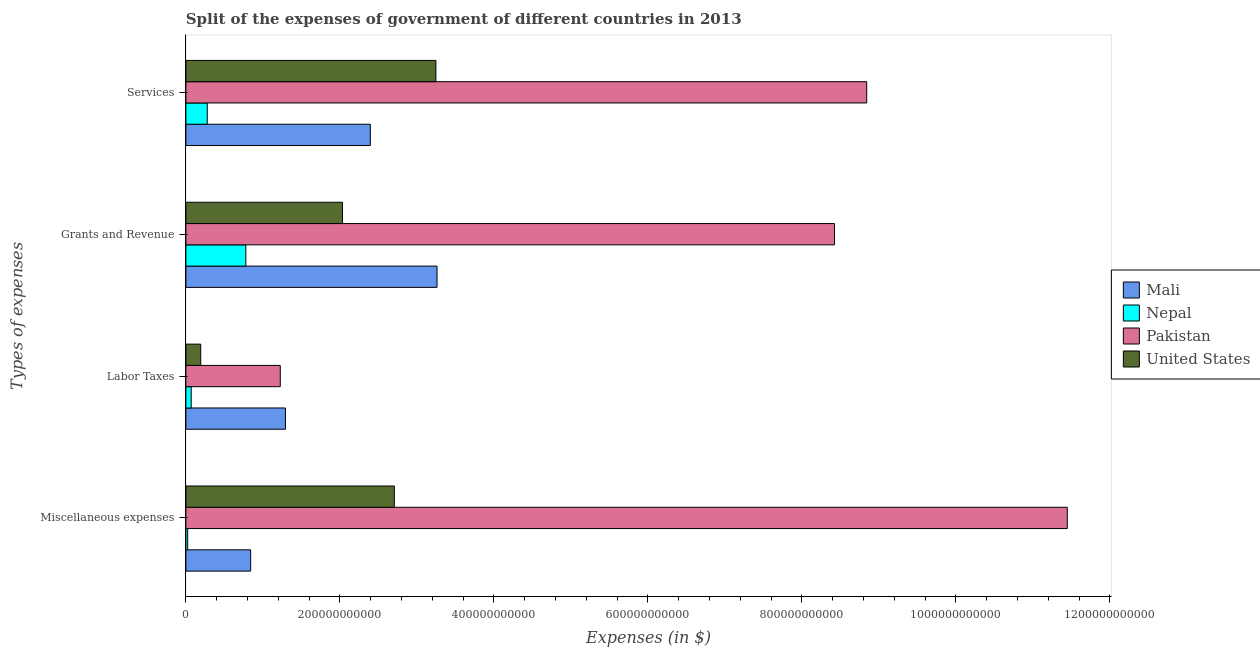How many different coloured bars are there?
Offer a terse response. 4. Are the number of bars on each tick of the Y-axis equal?
Provide a short and direct response. Yes. What is the label of the 3rd group of bars from the top?
Ensure brevity in your answer.  Labor Taxes. What is the amount spent on services in Mali?
Make the answer very short. 2.40e+11. Across all countries, what is the maximum amount spent on miscellaneous expenses?
Your response must be concise. 1.14e+12. Across all countries, what is the minimum amount spent on miscellaneous expenses?
Provide a short and direct response. 2.33e+09. In which country was the amount spent on miscellaneous expenses maximum?
Your answer should be compact. Pakistan. In which country was the amount spent on grants and revenue minimum?
Your response must be concise. Nepal. What is the total amount spent on grants and revenue in the graph?
Ensure brevity in your answer.  1.45e+12. What is the difference between the amount spent on services in Nepal and that in Mali?
Give a very brief answer. -2.12e+11. What is the difference between the amount spent on services in Pakistan and the amount spent on labor taxes in Mali?
Your answer should be compact. 7.55e+11. What is the average amount spent on services per country?
Offer a very short reply. 3.69e+11. What is the difference between the amount spent on services and amount spent on grants and revenue in Nepal?
Your answer should be very brief. -5.01e+1. What is the ratio of the amount spent on miscellaneous expenses in United States to that in Pakistan?
Give a very brief answer. 0.24. Is the difference between the amount spent on grants and revenue in Mali and Nepal greater than the difference between the amount spent on miscellaneous expenses in Mali and Nepal?
Ensure brevity in your answer.  Yes. What is the difference between the highest and the second highest amount spent on services?
Provide a succinct answer. 5.60e+11. What is the difference between the highest and the lowest amount spent on services?
Give a very brief answer. 8.56e+11. In how many countries, is the amount spent on grants and revenue greater than the average amount spent on grants and revenue taken over all countries?
Give a very brief answer. 1. What does the 4th bar from the top in Miscellaneous expenses represents?
Give a very brief answer. Mali. What does the 4th bar from the bottom in Miscellaneous expenses represents?
Offer a terse response. United States. Is it the case that in every country, the sum of the amount spent on miscellaneous expenses and amount spent on labor taxes is greater than the amount spent on grants and revenue?
Your answer should be very brief. No. How many bars are there?
Your response must be concise. 16. What is the difference between two consecutive major ticks on the X-axis?
Your response must be concise. 2.00e+11. Does the graph contain any zero values?
Your answer should be very brief. No. Does the graph contain grids?
Your answer should be very brief. No. How are the legend labels stacked?
Provide a short and direct response. Vertical. What is the title of the graph?
Offer a terse response. Split of the expenses of government of different countries in 2013. Does "Sao Tome and Principe" appear as one of the legend labels in the graph?
Offer a terse response. No. What is the label or title of the X-axis?
Your answer should be very brief. Expenses (in $). What is the label or title of the Y-axis?
Provide a short and direct response. Types of expenses. What is the Expenses (in $) in Mali in Miscellaneous expenses?
Offer a very short reply. 8.41e+1. What is the Expenses (in $) in Nepal in Miscellaneous expenses?
Your response must be concise. 2.33e+09. What is the Expenses (in $) of Pakistan in Miscellaneous expenses?
Make the answer very short. 1.14e+12. What is the Expenses (in $) of United States in Miscellaneous expenses?
Make the answer very short. 2.71e+11. What is the Expenses (in $) in Mali in Labor Taxes?
Your answer should be very brief. 1.29e+11. What is the Expenses (in $) of Nepal in Labor Taxes?
Provide a short and direct response. 6.92e+09. What is the Expenses (in $) in Pakistan in Labor Taxes?
Offer a terse response. 1.23e+11. What is the Expenses (in $) in United States in Labor Taxes?
Your answer should be very brief. 1.93e+1. What is the Expenses (in $) of Mali in Grants and Revenue?
Ensure brevity in your answer.  3.26e+11. What is the Expenses (in $) of Nepal in Grants and Revenue?
Offer a very short reply. 7.79e+1. What is the Expenses (in $) of Pakistan in Grants and Revenue?
Your answer should be compact. 8.42e+11. What is the Expenses (in $) of United States in Grants and Revenue?
Your answer should be very brief. 2.03e+11. What is the Expenses (in $) in Mali in Services?
Provide a short and direct response. 2.40e+11. What is the Expenses (in $) of Nepal in Services?
Offer a terse response. 2.78e+1. What is the Expenses (in $) of Pakistan in Services?
Give a very brief answer. 8.84e+11. What is the Expenses (in $) of United States in Services?
Your response must be concise. 3.25e+11. Across all Types of expenses, what is the maximum Expenses (in $) of Mali?
Ensure brevity in your answer.  3.26e+11. Across all Types of expenses, what is the maximum Expenses (in $) in Nepal?
Give a very brief answer. 7.79e+1. Across all Types of expenses, what is the maximum Expenses (in $) of Pakistan?
Make the answer very short. 1.14e+12. Across all Types of expenses, what is the maximum Expenses (in $) of United States?
Your answer should be compact. 3.25e+11. Across all Types of expenses, what is the minimum Expenses (in $) in Mali?
Your answer should be compact. 8.41e+1. Across all Types of expenses, what is the minimum Expenses (in $) in Nepal?
Provide a short and direct response. 2.33e+09. Across all Types of expenses, what is the minimum Expenses (in $) of Pakistan?
Provide a short and direct response. 1.23e+11. Across all Types of expenses, what is the minimum Expenses (in $) in United States?
Your response must be concise. 1.93e+1. What is the total Expenses (in $) in Mali in the graph?
Offer a very short reply. 7.79e+11. What is the total Expenses (in $) of Nepal in the graph?
Give a very brief answer. 1.15e+11. What is the total Expenses (in $) of Pakistan in the graph?
Keep it short and to the point. 2.99e+12. What is the total Expenses (in $) of United States in the graph?
Keep it short and to the point. 8.18e+11. What is the difference between the Expenses (in $) of Mali in Miscellaneous expenses and that in Labor Taxes?
Provide a succinct answer. -4.52e+1. What is the difference between the Expenses (in $) of Nepal in Miscellaneous expenses and that in Labor Taxes?
Your answer should be compact. -4.59e+09. What is the difference between the Expenses (in $) in Pakistan in Miscellaneous expenses and that in Labor Taxes?
Provide a succinct answer. 1.02e+12. What is the difference between the Expenses (in $) in United States in Miscellaneous expenses and that in Labor Taxes?
Your response must be concise. 2.51e+11. What is the difference between the Expenses (in $) in Mali in Miscellaneous expenses and that in Grants and Revenue?
Provide a succinct answer. -2.42e+11. What is the difference between the Expenses (in $) of Nepal in Miscellaneous expenses and that in Grants and Revenue?
Provide a succinct answer. -7.55e+1. What is the difference between the Expenses (in $) in Pakistan in Miscellaneous expenses and that in Grants and Revenue?
Your answer should be compact. 3.02e+11. What is the difference between the Expenses (in $) in United States in Miscellaneous expenses and that in Grants and Revenue?
Offer a very short reply. 6.73e+1. What is the difference between the Expenses (in $) in Mali in Miscellaneous expenses and that in Services?
Your answer should be very brief. -1.55e+11. What is the difference between the Expenses (in $) in Nepal in Miscellaneous expenses and that in Services?
Offer a very short reply. -2.54e+1. What is the difference between the Expenses (in $) in Pakistan in Miscellaneous expenses and that in Services?
Your answer should be compact. 2.60e+11. What is the difference between the Expenses (in $) of United States in Miscellaneous expenses and that in Services?
Ensure brevity in your answer.  -5.40e+1. What is the difference between the Expenses (in $) in Mali in Labor Taxes and that in Grants and Revenue?
Provide a short and direct response. -1.97e+11. What is the difference between the Expenses (in $) of Nepal in Labor Taxes and that in Grants and Revenue?
Offer a terse response. -7.10e+1. What is the difference between the Expenses (in $) of Pakistan in Labor Taxes and that in Grants and Revenue?
Offer a very short reply. -7.20e+11. What is the difference between the Expenses (in $) in United States in Labor Taxes and that in Grants and Revenue?
Provide a succinct answer. -1.84e+11. What is the difference between the Expenses (in $) in Mali in Labor Taxes and that in Services?
Give a very brief answer. -1.10e+11. What is the difference between the Expenses (in $) in Nepal in Labor Taxes and that in Services?
Make the answer very short. -2.08e+1. What is the difference between the Expenses (in $) in Pakistan in Labor Taxes and that in Services?
Offer a terse response. -7.62e+11. What is the difference between the Expenses (in $) of United States in Labor Taxes and that in Services?
Provide a short and direct response. -3.05e+11. What is the difference between the Expenses (in $) of Mali in Grants and Revenue and that in Services?
Ensure brevity in your answer.  8.66e+1. What is the difference between the Expenses (in $) of Nepal in Grants and Revenue and that in Services?
Provide a succinct answer. 5.01e+1. What is the difference between the Expenses (in $) of Pakistan in Grants and Revenue and that in Services?
Ensure brevity in your answer.  -4.19e+1. What is the difference between the Expenses (in $) in United States in Grants and Revenue and that in Services?
Ensure brevity in your answer.  -1.21e+11. What is the difference between the Expenses (in $) in Mali in Miscellaneous expenses and the Expenses (in $) in Nepal in Labor Taxes?
Give a very brief answer. 7.72e+1. What is the difference between the Expenses (in $) in Mali in Miscellaneous expenses and the Expenses (in $) in Pakistan in Labor Taxes?
Offer a terse response. -3.84e+1. What is the difference between the Expenses (in $) of Mali in Miscellaneous expenses and the Expenses (in $) of United States in Labor Taxes?
Ensure brevity in your answer.  6.48e+1. What is the difference between the Expenses (in $) in Nepal in Miscellaneous expenses and the Expenses (in $) in Pakistan in Labor Taxes?
Keep it short and to the point. -1.20e+11. What is the difference between the Expenses (in $) in Nepal in Miscellaneous expenses and the Expenses (in $) in United States in Labor Taxes?
Your answer should be very brief. -1.70e+1. What is the difference between the Expenses (in $) in Pakistan in Miscellaneous expenses and the Expenses (in $) in United States in Labor Taxes?
Your answer should be very brief. 1.13e+12. What is the difference between the Expenses (in $) in Mali in Miscellaneous expenses and the Expenses (in $) in Nepal in Grants and Revenue?
Give a very brief answer. 6.26e+09. What is the difference between the Expenses (in $) in Mali in Miscellaneous expenses and the Expenses (in $) in Pakistan in Grants and Revenue?
Give a very brief answer. -7.58e+11. What is the difference between the Expenses (in $) in Mali in Miscellaneous expenses and the Expenses (in $) in United States in Grants and Revenue?
Your answer should be very brief. -1.19e+11. What is the difference between the Expenses (in $) of Nepal in Miscellaneous expenses and the Expenses (in $) of Pakistan in Grants and Revenue?
Give a very brief answer. -8.40e+11. What is the difference between the Expenses (in $) in Nepal in Miscellaneous expenses and the Expenses (in $) in United States in Grants and Revenue?
Offer a terse response. -2.01e+11. What is the difference between the Expenses (in $) of Pakistan in Miscellaneous expenses and the Expenses (in $) of United States in Grants and Revenue?
Your response must be concise. 9.41e+11. What is the difference between the Expenses (in $) in Mali in Miscellaneous expenses and the Expenses (in $) in Nepal in Services?
Offer a terse response. 5.64e+1. What is the difference between the Expenses (in $) in Mali in Miscellaneous expenses and the Expenses (in $) in Pakistan in Services?
Give a very brief answer. -8.00e+11. What is the difference between the Expenses (in $) in Mali in Miscellaneous expenses and the Expenses (in $) in United States in Services?
Provide a short and direct response. -2.41e+11. What is the difference between the Expenses (in $) in Nepal in Miscellaneous expenses and the Expenses (in $) in Pakistan in Services?
Give a very brief answer. -8.82e+11. What is the difference between the Expenses (in $) in Nepal in Miscellaneous expenses and the Expenses (in $) in United States in Services?
Keep it short and to the point. -3.22e+11. What is the difference between the Expenses (in $) in Pakistan in Miscellaneous expenses and the Expenses (in $) in United States in Services?
Ensure brevity in your answer.  8.20e+11. What is the difference between the Expenses (in $) in Mali in Labor Taxes and the Expenses (in $) in Nepal in Grants and Revenue?
Your answer should be very brief. 5.15e+1. What is the difference between the Expenses (in $) of Mali in Labor Taxes and the Expenses (in $) of Pakistan in Grants and Revenue?
Offer a very short reply. -7.13e+11. What is the difference between the Expenses (in $) in Mali in Labor Taxes and the Expenses (in $) in United States in Grants and Revenue?
Your response must be concise. -7.41e+1. What is the difference between the Expenses (in $) of Nepal in Labor Taxes and the Expenses (in $) of Pakistan in Grants and Revenue?
Your response must be concise. -8.35e+11. What is the difference between the Expenses (in $) in Nepal in Labor Taxes and the Expenses (in $) in United States in Grants and Revenue?
Offer a very short reply. -1.96e+11. What is the difference between the Expenses (in $) in Pakistan in Labor Taxes and the Expenses (in $) in United States in Grants and Revenue?
Ensure brevity in your answer.  -8.08e+1. What is the difference between the Expenses (in $) in Mali in Labor Taxes and the Expenses (in $) in Nepal in Services?
Provide a short and direct response. 1.02e+11. What is the difference between the Expenses (in $) of Mali in Labor Taxes and the Expenses (in $) of Pakistan in Services?
Provide a succinct answer. -7.55e+11. What is the difference between the Expenses (in $) in Mali in Labor Taxes and the Expenses (in $) in United States in Services?
Your response must be concise. -1.95e+11. What is the difference between the Expenses (in $) of Nepal in Labor Taxes and the Expenses (in $) of Pakistan in Services?
Your answer should be compact. -8.77e+11. What is the difference between the Expenses (in $) in Nepal in Labor Taxes and the Expenses (in $) in United States in Services?
Your answer should be very brief. -3.18e+11. What is the difference between the Expenses (in $) of Pakistan in Labor Taxes and the Expenses (in $) of United States in Services?
Make the answer very short. -2.02e+11. What is the difference between the Expenses (in $) in Mali in Grants and Revenue and the Expenses (in $) in Nepal in Services?
Your response must be concise. 2.98e+11. What is the difference between the Expenses (in $) in Mali in Grants and Revenue and the Expenses (in $) in Pakistan in Services?
Offer a terse response. -5.58e+11. What is the difference between the Expenses (in $) in Mali in Grants and Revenue and the Expenses (in $) in United States in Services?
Your answer should be compact. 1.47e+09. What is the difference between the Expenses (in $) in Nepal in Grants and Revenue and the Expenses (in $) in Pakistan in Services?
Give a very brief answer. -8.06e+11. What is the difference between the Expenses (in $) in Nepal in Grants and Revenue and the Expenses (in $) in United States in Services?
Make the answer very short. -2.47e+11. What is the difference between the Expenses (in $) in Pakistan in Grants and Revenue and the Expenses (in $) in United States in Services?
Offer a very short reply. 5.18e+11. What is the average Expenses (in $) in Mali per Types of expenses?
Your response must be concise. 1.95e+11. What is the average Expenses (in $) in Nepal per Types of expenses?
Provide a succinct answer. 2.87e+1. What is the average Expenses (in $) in Pakistan per Types of expenses?
Your answer should be very brief. 7.48e+11. What is the average Expenses (in $) of United States per Types of expenses?
Offer a very short reply. 2.05e+11. What is the difference between the Expenses (in $) of Mali and Expenses (in $) of Nepal in Miscellaneous expenses?
Your response must be concise. 8.18e+1. What is the difference between the Expenses (in $) in Mali and Expenses (in $) in Pakistan in Miscellaneous expenses?
Keep it short and to the point. -1.06e+12. What is the difference between the Expenses (in $) in Mali and Expenses (in $) in United States in Miscellaneous expenses?
Provide a succinct answer. -1.87e+11. What is the difference between the Expenses (in $) of Nepal and Expenses (in $) of Pakistan in Miscellaneous expenses?
Offer a very short reply. -1.14e+12. What is the difference between the Expenses (in $) in Nepal and Expenses (in $) in United States in Miscellaneous expenses?
Your response must be concise. -2.68e+11. What is the difference between the Expenses (in $) of Pakistan and Expenses (in $) of United States in Miscellaneous expenses?
Make the answer very short. 8.74e+11. What is the difference between the Expenses (in $) of Mali and Expenses (in $) of Nepal in Labor Taxes?
Your answer should be very brief. 1.22e+11. What is the difference between the Expenses (in $) of Mali and Expenses (in $) of Pakistan in Labor Taxes?
Keep it short and to the point. 6.76e+09. What is the difference between the Expenses (in $) of Mali and Expenses (in $) of United States in Labor Taxes?
Make the answer very short. 1.10e+11. What is the difference between the Expenses (in $) in Nepal and Expenses (in $) in Pakistan in Labor Taxes?
Your answer should be compact. -1.16e+11. What is the difference between the Expenses (in $) in Nepal and Expenses (in $) in United States in Labor Taxes?
Provide a succinct answer. -1.24e+1. What is the difference between the Expenses (in $) in Pakistan and Expenses (in $) in United States in Labor Taxes?
Your answer should be very brief. 1.03e+11. What is the difference between the Expenses (in $) of Mali and Expenses (in $) of Nepal in Grants and Revenue?
Offer a very short reply. 2.48e+11. What is the difference between the Expenses (in $) of Mali and Expenses (in $) of Pakistan in Grants and Revenue?
Give a very brief answer. -5.16e+11. What is the difference between the Expenses (in $) in Mali and Expenses (in $) in United States in Grants and Revenue?
Your response must be concise. 1.23e+11. What is the difference between the Expenses (in $) in Nepal and Expenses (in $) in Pakistan in Grants and Revenue?
Provide a short and direct response. -7.64e+11. What is the difference between the Expenses (in $) of Nepal and Expenses (in $) of United States in Grants and Revenue?
Offer a terse response. -1.26e+11. What is the difference between the Expenses (in $) of Pakistan and Expenses (in $) of United States in Grants and Revenue?
Offer a very short reply. 6.39e+11. What is the difference between the Expenses (in $) of Mali and Expenses (in $) of Nepal in Services?
Make the answer very short. 2.12e+11. What is the difference between the Expenses (in $) in Mali and Expenses (in $) in Pakistan in Services?
Make the answer very short. -6.45e+11. What is the difference between the Expenses (in $) of Mali and Expenses (in $) of United States in Services?
Make the answer very short. -8.52e+1. What is the difference between the Expenses (in $) in Nepal and Expenses (in $) in Pakistan in Services?
Offer a very short reply. -8.56e+11. What is the difference between the Expenses (in $) of Nepal and Expenses (in $) of United States in Services?
Ensure brevity in your answer.  -2.97e+11. What is the difference between the Expenses (in $) in Pakistan and Expenses (in $) in United States in Services?
Ensure brevity in your answer.  5.60e+11. What is the ratio of the Expenses (in $) in Mali in Miscellaneous expenses to that in Labor Taxes?
Provide a succinct answer. 0.65. What is the ratio of the Expenses (in $) of Nepal in Miscellaneous expenses to that in Labor Taxes?
Provide a short and direct response. 0.34. What is the ratio of the Expenses (in $) of Pakistan in Miscellaneous expenses to that in Labor Taxes?
Your response must be concise. 9.34. What is the ratio of the Expenses (in $) of United States in Miscellaneous expenses to that in Labor Taxes?
Give a very brief answer. 14.03. What is the ratio of the Expenses (in $) in Mali in Miscellaneous expenses to that in Grants and Revenue?
Give a very brief answer. 0.26. What is the ratio of the Expenses (in $) in Nepal in Miscellaneous expenses to that in Grants and Revenue?
Give a very brief answer. 0.03. What is the ratio of the Expenses (in $) of Pakistan in Miscellaneous expenses to that in Grants and Revenue?
Offer a very short reply. 1.36. What is the ratio of the Expenses (in $) in United States in Miscellaneous expenses to that in Grants and Revenue?
Ensure brevity in your answer.  1.33. What is the ratio of the Expenses (in $) of Mali in Miscellaneous expenses to that in Services?
Make the answer very short. 0.35. What is the ratio of the Expenses (in $) in Nepal in Miscellaneous expenses to that in Services?
Provide a short and direct response. 0.08. What is the ratio of the Expenses (in $) in Pakistan in Miscellaneous expenses to that in Services?
Keep it short and to the point. 1.29. What is the ratio of the Expenses (in $) of United States in Miscellaneous expenses to that in Services?
Give a very brief answer. 0.83. What is the ratio of the Expenses (in $) in Mali in Labor Taxes to that in Grants and Revenue?
Your answer should be very brief. 0.4. What is the ratio of the Expenses (in $) of Nepal in Labor Taxes to that in Grants and Revenue?
Provide a short and direct response. 0.09. What is the ratio of the Expenses (in $) of Pakistan in Labor Taxes to that in Grants and Revenue?
Your answer should be compact. 0.15. What is the ratio of the Expenses (in $) in United States in Labor Taxes to that in Grants and Revenue?
Your answer should be very brief. 0.09. What is the ratio of the Expenses (in $) in Mali in Labor Taxes to that in Services?
Your answer should be compact. 0.54. What is the ratio of the Expenses (in $) of Nepal in Labor Taxes to that in Services?
Make the answer very short. 0.25. What is the ratio of the Expenses (in $) of Pakistan in Labor Taxes to that in Services?
Provide a succinct answer. 0.14. What is the ratio of the Expenses (in $) of United States in Labor Taxes to that in Services?
Keep it short and to the point. 0.06. What is the ratio of the Expenses (in $) in Mali in Grants and Revenue to that in Services?
Your response must be concise. 1.36. What is the ratio of the Expenses (in $) in Nepal in Grants and Revenue to that in Services?
Your response must be concise. 2.81. What is the ratio of the Expenses (in $) in Pakistan in Grants and Revenue to that in Services?
Your answer should be very brief. 0.95. What is the ratio of the Expenses (in $) in United States in Grants and Revenue to that in Services?
Provide a short and direct response. 0.63. What is the difference between the highest and the second highest Expenses (in $) in Mali?
Provide a succinct answer. 8.66e+1. What is the difference between the highest and the second highest Expenses (in $) of Nepal?
Your response must be concise. 5.01e+1. What is the difference between the highest and the second highest Expenses (in $) of Pakistan?
Give a very brief answer. 2.60e+11. What is the difference between the highest and the second highest Expenses (in $) of United States?
Ensure brevity in your answer.  5.40e+1. What is the difference between the highest and the lowest Expenses (in $) of Mali?
Make the answer very short. 2.42e+11. What is the difference between the highest and the lowest Expenses (in $) in Nepal?
Give a very brief answer. 7.55e+1. What is the difference between the highest and the lowest Expenses (in $) in Pakistan?
Give a very brief answer. 1.02e+12. What is the difference between the highest and the lowest Expenses (in $) of United States?
Provide a short and direct response. 3.05e+11. 